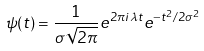Convert formula to latex. <formula><loc_0><loc_0><loc_500><loc_500>\psi ( t ) = \frac { 1 } { \sigma \sqrt { 2 \pi } } e ^ { 2 \pi i \lambda t } e ^ { - t ^ { 2 } / 2 \sigma ^ { 2 } }</formula> 